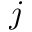Convert formula to latex. <formula><loc_0><loc_0><loc_500><loc_500>j</formula> 